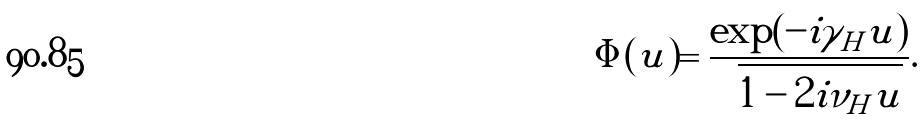<formula> <loc_0><loc_0><loc_500><loc_500>\Phi ( u ) = \frac { \exp ( - i \gamma _ { H } u ) } { \sqrt { 1 - 2 i \nu _ { H } u } } .</formula> 